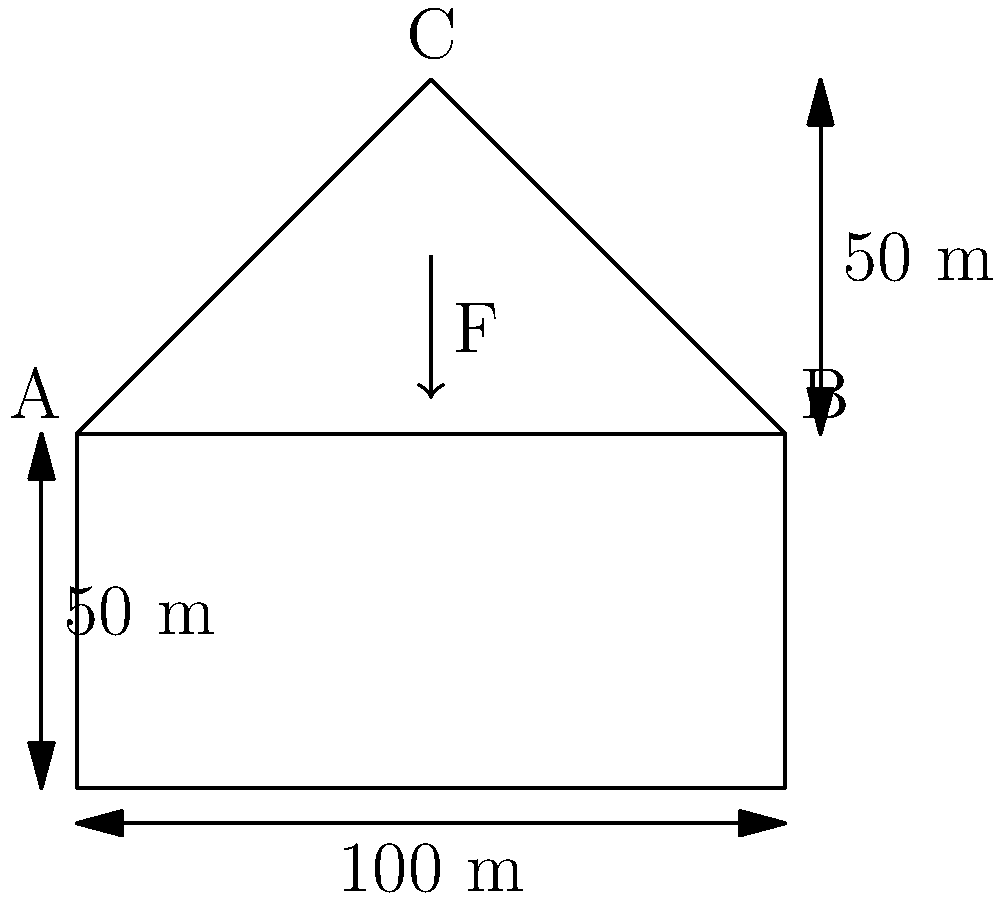As a baseball enthusiast designing a new stadium, you're considering a retractable roof structure. The roof is modeled as an isosceles triangle ABC with a base of 100 m and a height of 50 m. A vertical force F is applied at the apex (point C). If the maximum allowable stress in the roof members is 250 MPa and each member has a cross-sectional area of 0.1 m², what is the maximum force F that can be safely applied? Let's approach this step-by-step:

1) First, we need to calculate the length of the roof members AC and BC:
   Using the Pythagorean theorem:
   $AC^2 = BC^2 = 50^2 + 50^2 = 5000$
   $AC = BC = \sqrt{5000} = 50\sqrt{2}$ m

2) Now, let's consider the forces in the structure:
   Due to symmetry, the forces in members AC and BC will be equal. Let's call this force T.

3) For equilibrium at point C:
   $2T\sin{\theta} = F$, where $\theta$ is the angle between the roof member and the horizontal.

4) We can find $\sin{\theta}$:
   $\sin{\theta} = \frac{50}{50\sqrt{2}} = \frac{1}{\sqrt{2}}$

5) Substituting this into our equilibrium equation:
   $2T(\frac{1}{\sqrt{2}}) = F$
   $T = \frac{F\sqrt{2}}{2}$

6) The stress in each member is given by force divided by area:
   $\sigma = \frac{T}{A} = \frac{F\sqrt{2}}{2A}$

7) We're told that the maximum allowable stress is 250 MPa and the area is 0.1 m². Substituting these:
   $250 \times 10^6 = \frac{F\sqrt{2}}{2 \times 0.1}$

8) Solving for F:
   $F = \frac{250 \times 10^6 \times 2 \times 0.1}{\sqrt{2}} = 3.54 \times 10^6$ N

Therefore, the maximum force that can be safely applied is approximately 3.54 MN.
Answer: 3.54 MN 